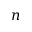Convert formula to latex. <formula><loc_0><loc_0><loc_500><loc_500>n</formula> 